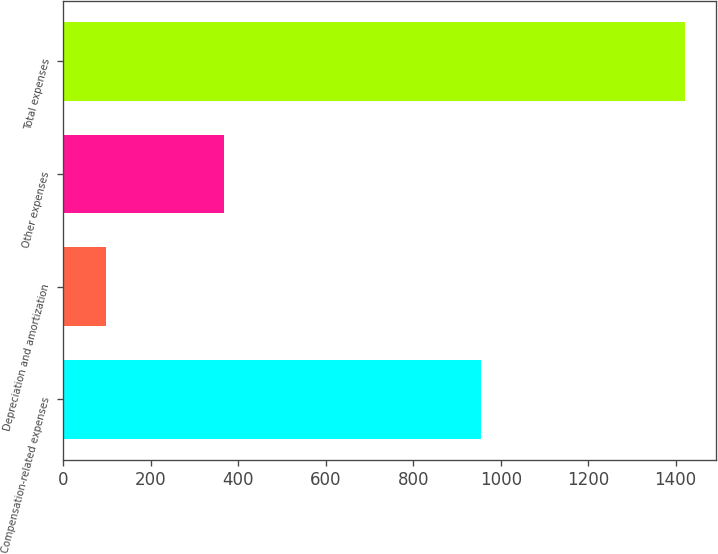<chart> <loc_0><loc_0><loc_500><loc_500><bar_chart><fcel>Compensation-related expenses<fcel>Depreciation and amortization<fcel>Other expenses<fcel>Total expenses<nl><fcel>955.8<fcel>98.2<fcel>367.4<fcel>1421.4<nl></chart> 